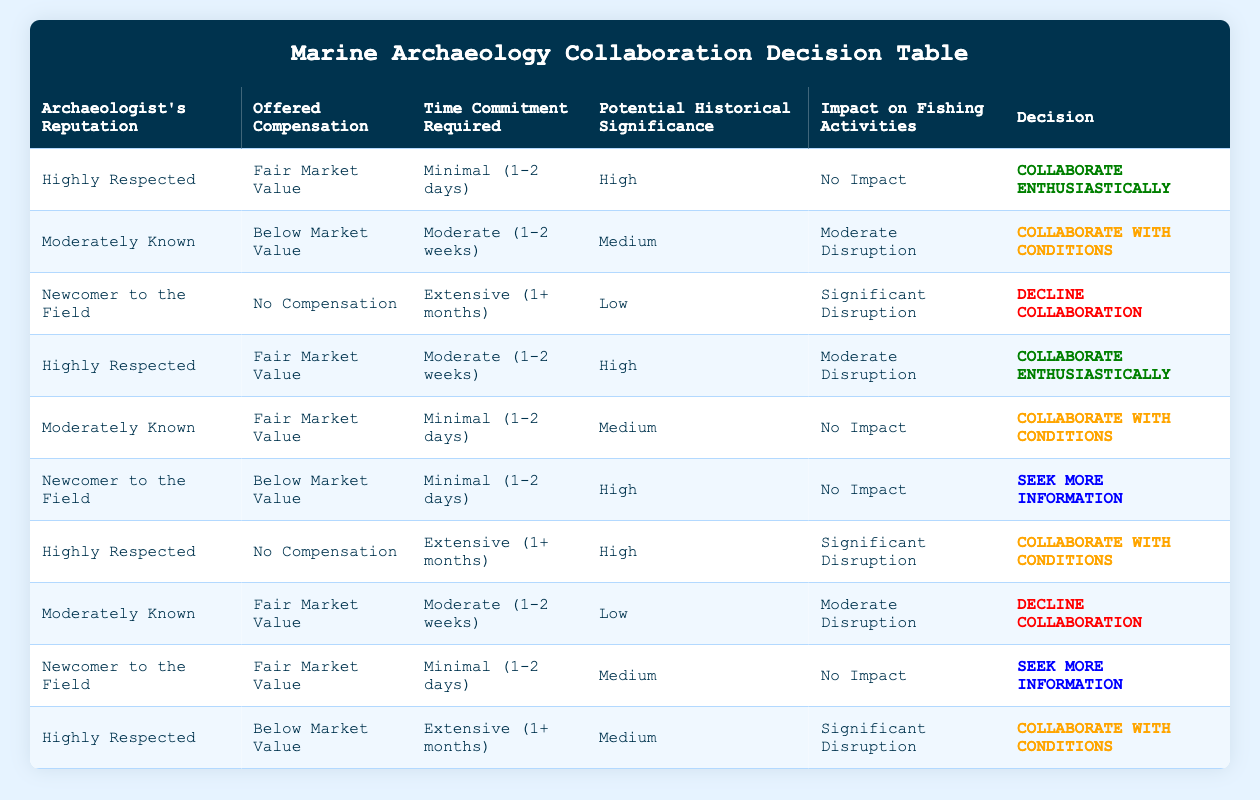What is the decision if the archaeologist's reputation is "Highly Respected" and the time commitment is "Minimal (1-2 days)"? Looking at the table, this exact scenario appears in the first row. The decision listed is "Collaborate Enthusiastically".
Answer: Collaborate Enthusiastically Is there a case where the offered compensation is "No Compensation"? By scanning the table, there are two rows with "No Compensation": the third row and the sixth row. The decisions for these cases are "Decline Collaboration" and "Collaborate with Conditions", respectively.
Answer: Yes What is the average time commitment for the decisions to "Collaborate with Conditions"? The relevant rows for "Collaborate with Conditions" are the second, sixth, and ninth rows. Their time commitments are "Moderate (1-2 weeks)", "Extensive (1+ months)", and "Minimal (1-2 days)". Converting them to a numerical scale, we can consider 1.5 weeks for "Moderate (1-2 weeks)", 5 weeks for "Extensive (1+ months)", and 1 week for "Minimal (1-2 days)", summing them gives 7.5 weeks and dividing by 3 gives an average of 2.5 weeks.
Answer: 2.5 weeks Are any decisions categorized as "Decline Collaboration" based on "Moderately Known" reputation? In the table, the decision for "Moderately Known" with "Fair Market Value" and "Moderate (1-2 weeks)" yields "Decline Collaboration", which is found in the eighth row.
Answer: Yes What is the decision if the archaeologist is a "Newcomer to the Field" and the compensation is at "Below Market Value"? In the table, this setup appears in the sixth row. The corresponding decision is "Seek More Information".
Answer: Seek More Information What is the highest potential historical significance associated with "Highly Respected" archaeologists? By reviewing the rows related to "Highly Respected", we identify two entries with "High" significance: the first and the fourth rows. Both decisions yield "Collaborate Enthusiastically."
Answer: Collaborate Enthusiastically Is there a scenario where both the time commitment is "Extensive (1+ months)" and there is "No Compensation"? Scanning through the table, there is one instance: the sixth row. The corresponding decision is "Collaborate with Conditions."
Answer: No What is the total number of decisions categorized as "Seek More Information"? Upon examination, both the sixth and ninth rows indicate "Seek More Information". Thus, there are two instances.
Answer: 2 What is the condition associated with "Collaborate Enthusiastically" for "Newcomer to the Field"? The table does not list any row that leads to "Collaborate Enthusiastically" for "Newcomer to the Field". The only decision for them is "Seek More Information".
Answer: None 